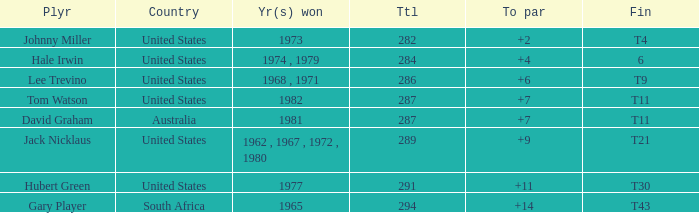WHAT IS THE TO PAR WITH A FINISH OF T11, FOR DAVID GRAHAM? 7.0. 